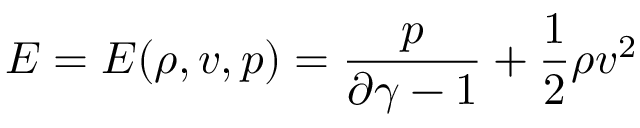Convert formula to latex. <formula><loc_0><loc_0><loc_500><loc_500>E = E ( \rho , v , p ) = \frac { p } { \partial \gamma - 1 } + \frac { 1 } { 2 } \rho v ^ { 2 }</formula> 